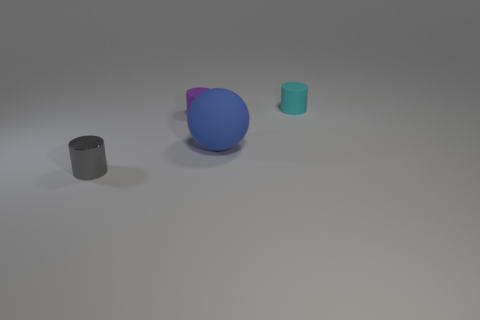Is there anything else that has the same color as the big ball?
Offer a very short reply. No. What is the size of the rubber cylinder that is on the right side of the tiny matte cylinder in front of the rubber object behind the tiny purple thing?
Ensure brevity in your answer.  Small. There is a thing that is both in front of the small purple matte object and to the left of the big matte sphere; what color is it?
Offer a very short reply. Gray. There is a matte thing on the right side of the blue sphere; how big is it?
Offer a terse response. Small. What number of large objects have the same material as the blue sphere?
Keep it short and to the point. 0. There is a tiny thing to the right of the large rubber ball; is its shape the same as the blue object?
Keep it short and to the point. No. What is the color of the ball that is the same material as the purple object?
Your answer should be very brief. Blue. Are there any cyan matte cylinders that are in front of the purple cylinder that is left of the thing that is right of the blue thing?
Your answer should be very brief. No. What is the shape of the tiny gray metal object?
Provide a succinct answer. Cylinder. Are there fewer matte objects in front of the blue rubber sphere than small metal cylinders?
Keep it short and to the point. Yes. 